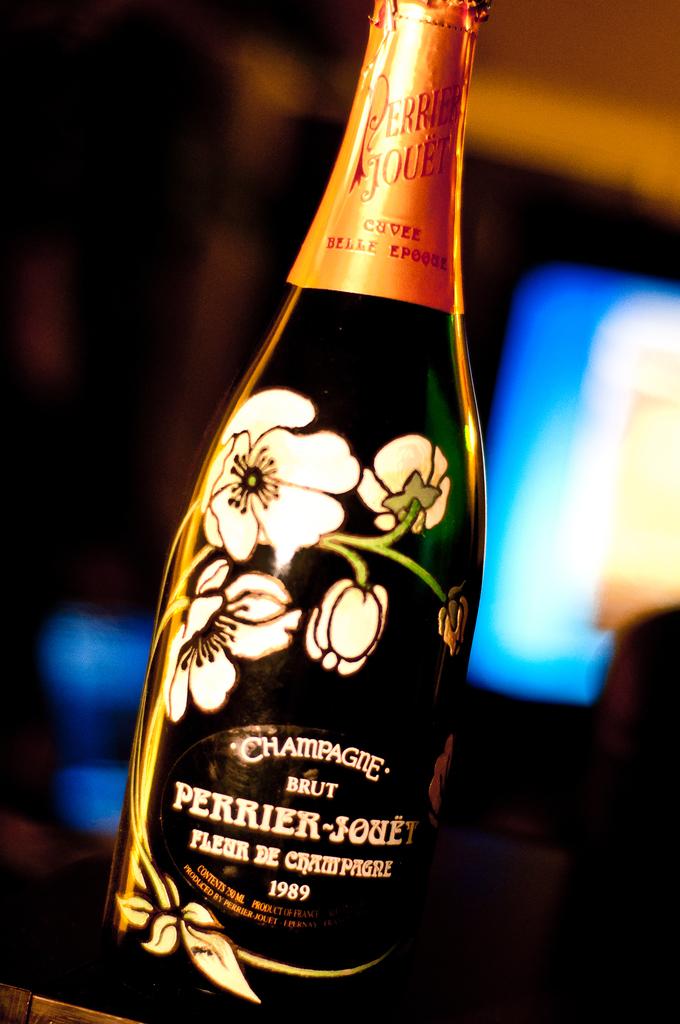What type of alcohol is in the bottle?
Your answer should be very brief. Champagne. What is the year on the bottle?
Keep it short and to the point. 1989. 